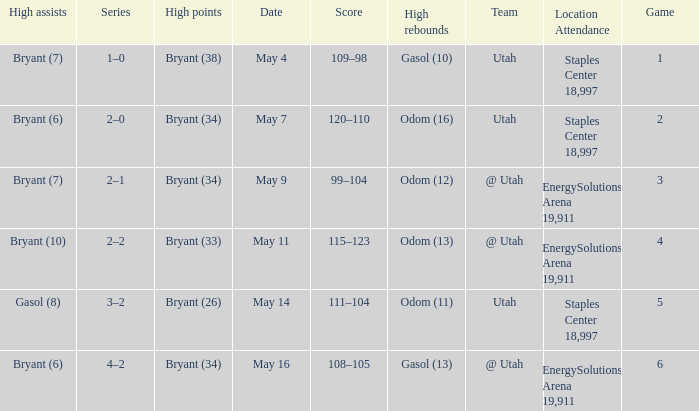What is the High rebounds with a High assists with bryant (7), and a Team of @ utah? Odom (12). 